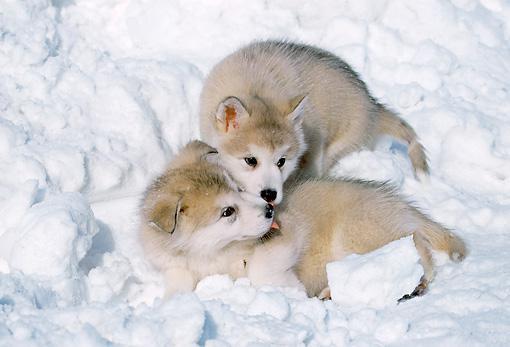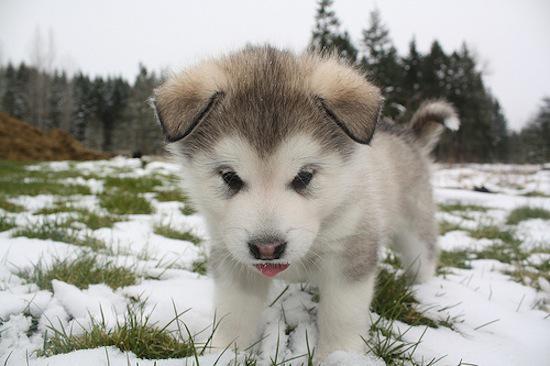The first image is the image on the left, the second image is the image on the right. Examine the images to the left and right. Is the description "At least one photo shows a single dog facing forward, standing on grass." accurate? Answer yes or no. Yes. The first image is the image on the left, the second image is the image on the right. Examine the images to the left and right. Is the description "The combined images show four puppies of the same breed in the snow." accurate? Answer yes or no. No. 